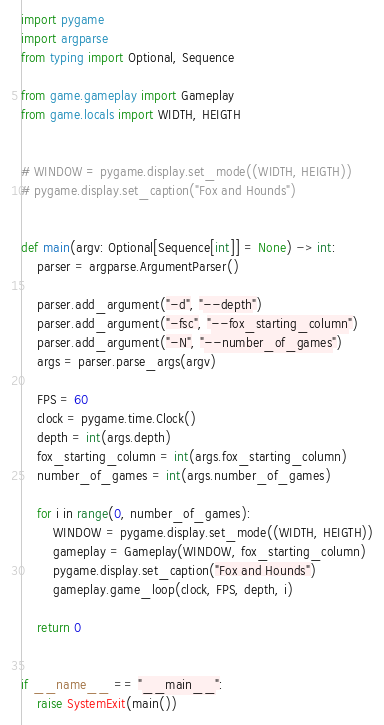<code> <loc_0><loc_0><loc_500><loc_500><_Python_>import pygame
import argparse
from typing import Optional, Sequence

from game.gameplay import Gameplay
from game.locals import WIDTH, HEIGTH


# WINDOW = pygame.display.set_mode((WIDTH, HEIGTH))
# pygame.display.set_caption("Fox and Hounds")


def main(argv: Optional[Sequence[int]] = None) -> int:
    parser = argparse.ArgumentParser()

    parser.add_argument("-d", "--depth")
    parser.add_argument("-fsc", "--fox_starting_column")
    parser.add_argument("-N", "--number_of_games")
    args = parser.parse_args(argv)

    FPS = 60
    clock = pygame.time.Clock()
    depth = int(args.depth)
    fox_starting_column = int(args.fox_starting_column)
    number_of_games = int(args.number_of_games)

    for i in range(0, number_of_games):
        WINDOW = pygame.display.set_mode((WIDTH, HEIGTH))
        gameplay = Gameplay(WINDOW, fox_starting_column)
        pygame.display.set_caption("Fox and Hounds")
        gameplay.game_loop(clock, FPS, depth, i)

    return 0


if __name__ == "__main__":
    raise SystemExit(main())
</code> 